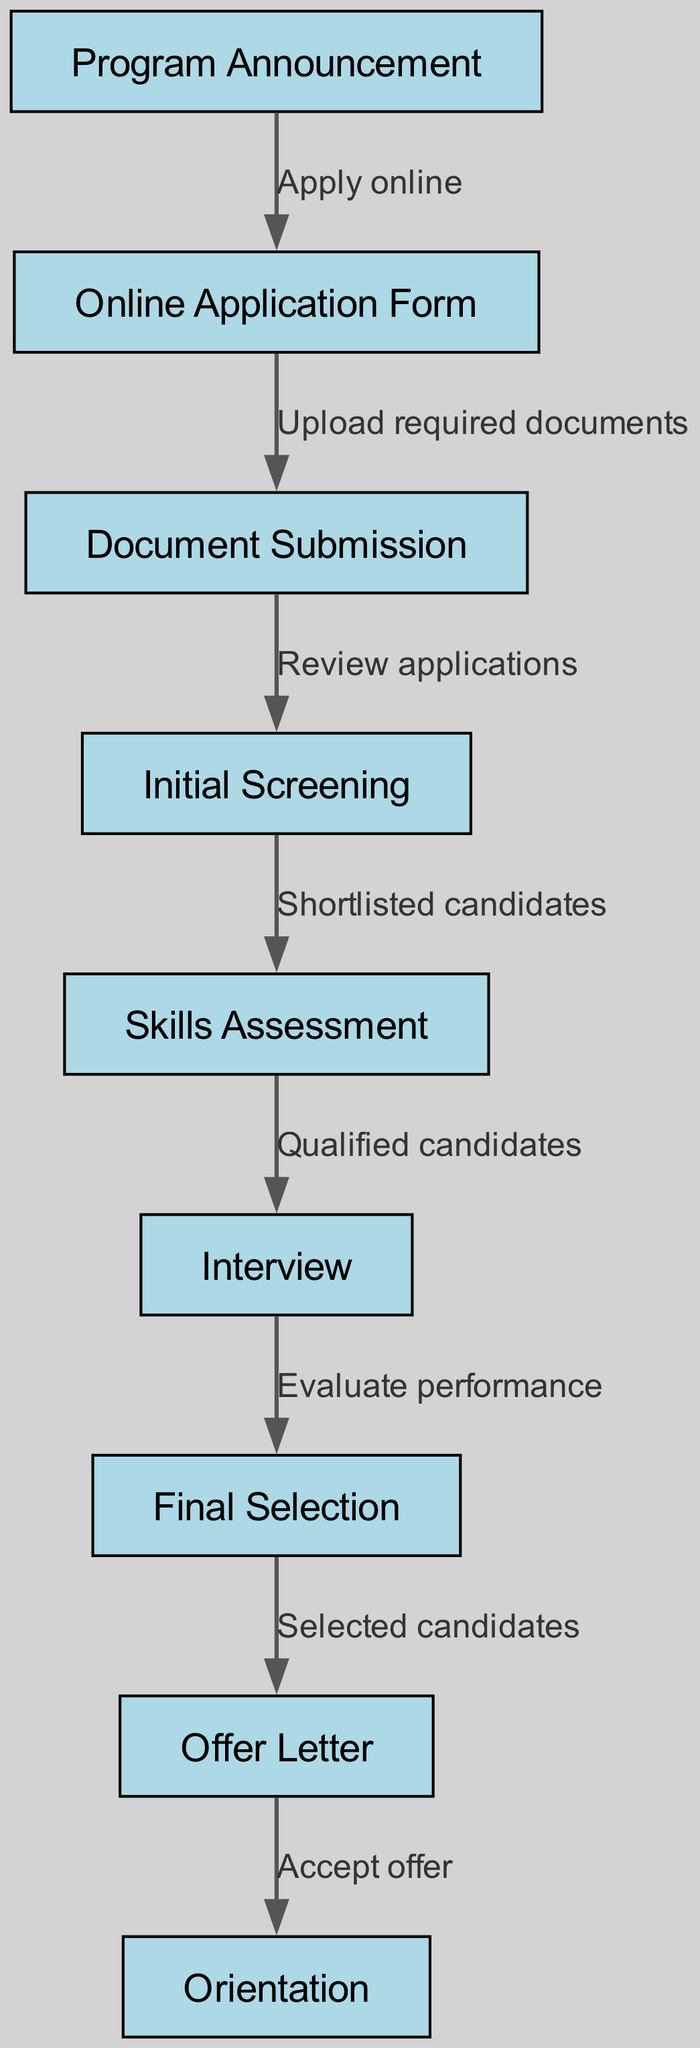What is the first step in the internship application process? The first step is labeled as "Program Announcement." This is indicated at the top of the flowchart, showing that it is the starting point of the entire process.
Answer: Program Announcement How many nodes are present in the diagram? By counting each unique step represented as a node in the diagram, there are a total of nine nodes listed in the nodes section: 1 through 9.
Answer: 9 What is the label of the node that follows "Initial Screening"? The node immediately following "Initial Screening" is labeled "Skills Assessment." The diagram clearly shows this by following the directed edge from node 4 to node 5.
Answer: Skills Assessment What is the final step of the selection process? The final step of the process is labeled "Orientation," which is the last node in the flowchart, depicting the conclusion of the internship program's selection process.
Answer: Orientation Which nodes represent the candidate evaluation stages? The nodes that pertain to candidate evaluation are "Initial Screening," "Skills Assessment," and "Interview." These nodes sequentially evaluate the candidates’ applications and abilities before making a final selection.
Answer: Initial Screening, Skills Assessment, Interview How many edges connect "Document Submission" to "Initial Screening"? There is one edge connecting "Document Submission" (node 3) to "Initial Screening" (node 4), indicating a single flow of the application process from submission to screening.
Answer: 1 What is the action taken when Candidates are selected in the process? Upon the selection of candidates, they are sent an "Offer Letter." This is clearly indicated by the edge connecting the "Final Selection" node to the "Offer Letter" node, showing what follows the selection.
Answer: Offer Letter How many steps are taken before the final selection? Before reaching the "Final Selection," there are four steps: "Initial Screening," "Skills Assessment," "Interview," and the selection itself. Counting these gives a total of four distinct steps leading up to that point.
Answer: 4 What must candidates do after receiving the offer letter? After receiving the "Offer Letter," candidates must "Accept offer." This shows the necessary action candidates must take to confirm their participation in the internship program.
Answer: Accept offer 